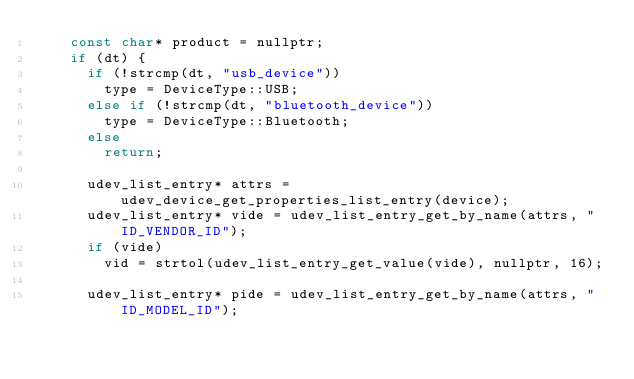Convert code to text. <code><loc_0><loc_0><loc_500><loc_500><_C++_>    const char* product = nullptr;
    if (dt) {
      if (!strcmp(dt, "usb_device"))
        type = DeviceType::USB;
      else if (!strcmp(dt, "bluetooth_device"))
        type = DeviceType::Bluetooth;
      else
        return;

      udev_list_entry* attrs = udev_device_get_properties_list_entry(device);
      udev_list_entry* vide = udev_list_entry_get_by_name(attrs, "ID_VENDOR_ID");
      if (vide)
        vid = strtol(udev_list_entry_get_value(vide), nullptr, 16);

      udev_list_entry* pide = udev_list_entry_get_by_name(attrs, "ID_MODEL_ID");</code> 